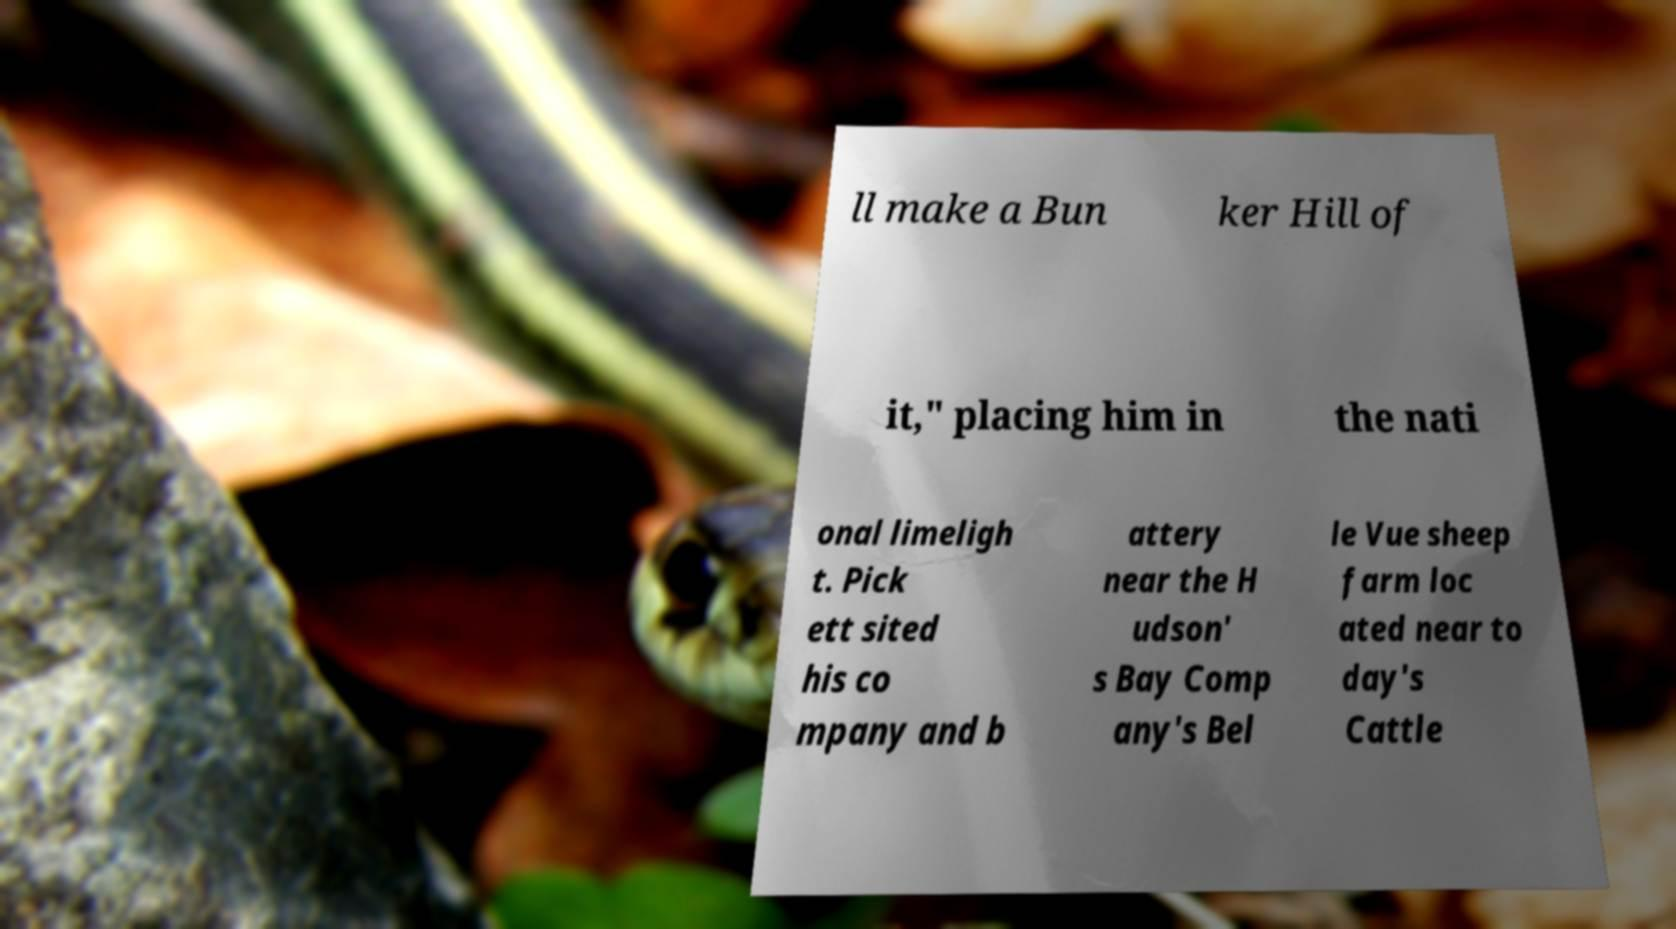Can you accurately transcribe the text from the provided image for me? ll make a Bun ker Hill of it," placing him in the nati onal limeligh t. Pick ett sited his co mpany and b attery near the H udson' s Bay Comp any's Bel le Vue sheep farm loc ated near to day's Cattle 